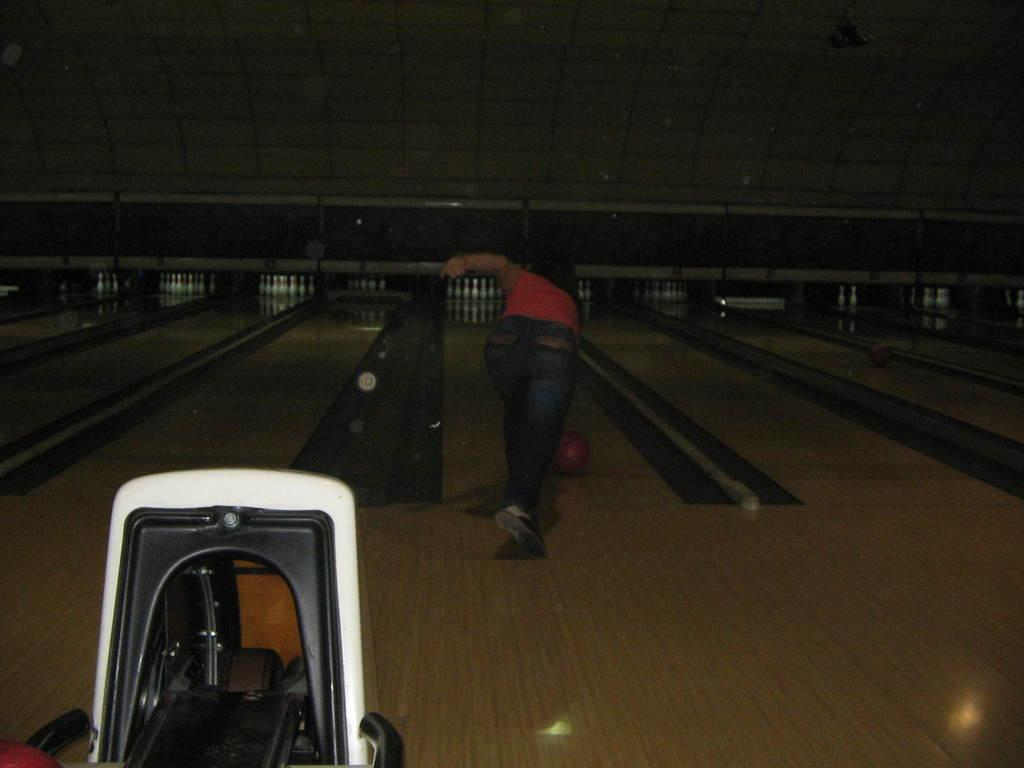What is the main object in the image? There is an object in the image, but the specific object is not mentioned in the facts. Can you describe the person in the image? A person is standing in the image, but no further details about the person are provided. What is on the platform in the image? There is a ball on a platform in the image. What can be seen in the background of the image? There are nine pin bowling sets and a wall visible in the background of the image. How many houses are visible in the image? There is no mention of houses in the image, so we cannot determine their number. Can you tell me the name of the stranger in the image? There is no mention of a stranger in the image, so we cannot provide their name. 